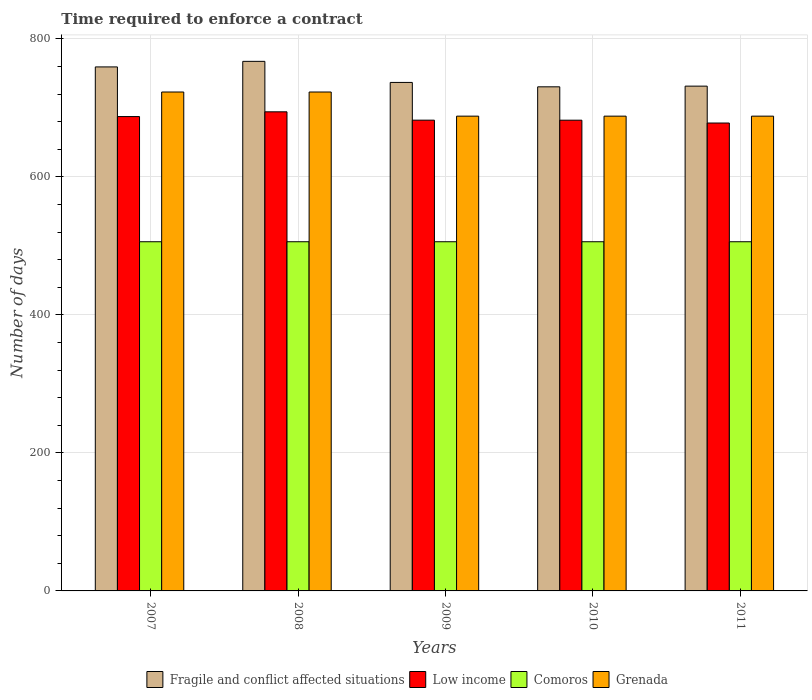How many groups of bars are there?
Give a very brief answer. 5. Are the number of bars on each tick of the X-axis equal?
Give a very brief answer. Yes. What is the label of the 4th group of bars from the left?
Offer a very short reply. 2010. What is the number of days required to enforce a contract in Low income in 2011?
Ensure brevity in your answer.  678.04. Across all years, what is the maximum number of days required to enforce a contract in Grenada?
Ensure brevity in your answer.  723. Across all years, what is the minimum number of days required to enforce a contract in Grenada?
Keep it short and to the point. 688. In which year was the number of days required to enforce a contract in Low income minimum?
Make the answer very short. 2011. What is the total number of days required to enforce a contract in Comoros in the graph?
Offer a very short reply. 2530. What is the difference between the number of days required to enforce a contract in Low income in 2007 and the number of days required to enforce a contract in Comoros in 2009?
Make the answer very short. 181.39. What is the average number of days required to enforce a contract in Grenada per year?
Provide a short and direct response. 702. In the year 2009, what is the difference between the number of days required to enforce a contract in Fragile and conflict affected situations and number of days required to enforce a contract in Grenada?
Your answer should be compact. 48.87. In how many years, is the number of days required to enforce a contract in Fragile and conflict affected situations greater than 360 days?
Offer a very short reply. 5. What is the ratio of the number of days required to enforce a contract in Low income in 2008 to that in 2011?
Provide a short and direct response. 1.02. What is the difference between the highest and the second highest number of days required to enforce a contract in Comoros?
Ensure brevity in your answer.  0. In how many years, is the number of days required to enforce a contract in Low income greater than the average number of days required to enforce a contract in Low income taken over all years?
Offer a terse response. 2. Is the sum of the number of days required to enforce a contract in Low income in 2009 and 2010 greater than the maximum number of days required to enforce a contract in Grenada across all years?
Your response must be concise. Yes. What does the 1st bar from the left in 2007 represents?
Ensure brevity in your answer.  Fragile and conflict affected situations. Is it the case that in every year, the sum of the number of days required to enforce a contract in Low income and number of days required to enforce a contract in Fragile and conflict affected situations is greater than the number of days required to enforce a contract in Grenada?
Your response must be concise. Yes. How many bars are there?
Provide a succinct answer. 20. Are the values on the major ticks of Y-axis written in scientific E-notation?
Offer a very short reply. No. Does the graph contain any zero values?
Ensure brevity in your answer.  No. Does the graph contain grids?
Keep it short and to the point. Yes. Where does the legend appear in the graph?
Keep it short and to the point. Bottom center. How many legend labels are there?
Your answer should be compact. 4. What is the title of the graph?
Provide a succinct answer. Time required to enforce a contract. Does "Malaysia" appear as one of the legend labels in the graph?
Provide a short and direct response. No. What is the label or title of the Y-axis?
Make the answer very short. Number of days. What is the Number of days of Fragile and conflict affected situations in 2007?
Provide a succinct answer. 759.34. What is the Number of days of Low income in 2007?
Make the answer very short. 687.39. What is the Number of days of Comoros in 2007?
Give a very brief answer. 506. What is the Number of days in Grenada in 2007?
Offer a terse response. 723. What is the Number of days in Fragile and conflict affected situations in 2008?
Keep it short and to the point. 767.41. What is the Number of days in Low income in 2008?
Offer a very short reply. 694.29. What is the Number of days of Comoros in 2008?
Your answer should be compact. 506. What is the Number of days in Grenada in 2008?
Offer a very short reply. 723. What is the Number of days of Fragile and conflict affected situations in 2009?
Make the answer very short. 736.87. What is the Number of days of Low income in 2009?
Give a very brief answer. 682.18. What is the Number of days of Comoros in 2009?
Provide a short and direct response. 506. What is the Number of days in Grenada in 2009?
Ensure brevity in your answer.  688. What is the Number of days in Fragile and conflict affected situations in 2010?
Keep it short and to the point. 730.5. What is the Number of days in Low income in 2010?
Ensure brevity in your answer.  682.14. What is the Number of days of Comoros in 2010?
Keep it short and to the point. 506. What is the Number of days in Grenada in 2010?
Offer a terse response. 688. What is the Number of days in Fragile and conflict affected situations in 2011?
Ensure brevity in your answer.  731.5. What is the Number of days of Low income in 2011?
Ensure brevity in your answer.  678.04. What is the Number of days of Comoros in 2011?
Your answer should be very brief. 506. What is the Number of days in Grenada in 2011?
Your answer should be very brief. 688. Across all years, what is the maximum Number of days in Fragile and conflict affected situations?
Your answer should be compact. 767.41. Across all years, what is the maximum Number of days of Low income?
Provide a succinct answer. 694.29. Across all years, what is the maximum Number of days in Comoros?
Ensure brevity in your answer.  506. Across all years, what is the maximum Number of days of Grenada?
Your answer should be compact. 723. Across all years, what is the minimum Number of days in Fragile and conflict affected situations?
Your answer should be compact. 730.5. Across all years, what is the minimum Number of days in Low income?
Offer a terse response. 678.04. Across all years, what is the minimum Number of days of Comoros?
Offer a terse response. 506. Across all years, what is the minimum Number of days of Grenada?
Offer a very short reply. 688. What is the total Number of days in Fragile and conflict affected situations in the graph?
Offer a terse response. 3725.63. What is the total Number of days of Low income in the graph?
Ensure brevity in your answer.  3424.04. What is the total Number of days of Comoros in the graph?
Your answer should be very brief. 2530. What is the total Number of days in Grenada in the graph?
Ensure brevity in your answer.  3510. What is the difference between the Number of days in Fragile and conflict affected situations in 2007 and that in 2008?
Offer a very short reply. -8.07. What is the difference between the Number of days in Low income in 2007 and that in 2008?
Ensure brevity in your answer.  -6.89. What is the difference between the Number of days of Grenada in 2007 and that in 2008?
Provide a short and direct response. 0. What is the difference between the Number of days in Fragile and conflict affected situations in 2007 and that in 2009?
Offer a terse response. 22.48. What is the difference between the Number of days of Low income in 2007 and that in 2009?
Keep it short and to the point. 5.21. What is the difference between the Number of days in Fragile and conflict affected situations in 2007 and that in 2010?
Provide a short and direct response. 28.84. What is the difference between the Number of days in Low income in 2007 and that in 2010?
Keep it short and to the point. 5.25. What is the difference between the Number of days of Comoros in 2007 and that in 2010?
Provide a short and direct response. 0. What is the difference between the Number of days in Grenada in 2007 and that in 2010?
Give a very brief answer. 35. What is the difference between the Number of days of Fragile and conflict affected situations in 2007 and that in 2011?
Ensure brevity in your answer.  27.84. What is the difference between the Number of days in Low income in 2007 and that in 2011?
Give a very brief answer. 9.36. What is the difference between the Number of days in Comoros in 2007 and that in 2011?
Offer a very short reply. 0. What is the difference between the Number of days of Fragile and conflict affected situations in 2008 and that in 2009?
Offer a terse response. 30.55. What is the difference between the Number of days of Low income in 2008 and that in 2009?
Your response must be concise. 12.11. What is the difference between the Number of days of Comoros in 2008 and that in 2009?
Keep it short and to the point. 0. What is the difference between the Number of days of Fragile and conflict affected situations in 2008 and that in 2010?
Offer a very short reply. 36.91. What is the difference between the Number of days in Low income in 2008 and that in 2010?
Give a very brief answer. 12.14. What is the difference between the Number of days in Fragile and conflict affected situations in 2008 and that in 2011?
Offer a very short reply. 35.91. What is the difference between the Number of days of Low income in 2008 and that in 2011?
Provide a short and direct response. 16.25. What is the difference between the Number of days in Grenada in 2008 and that in 2011?
Your answer should be compact. 35. What is the difference between the Number of days of Fragile and conflict affected situations in 2009 and that in 2010?
Keep it short and to the point. 6.37. What is the difference between the Number of days of Low income in 2009 and that in 2010?
Make the answer very short. 0.04. What is the difference between the Number of days of Fragile and conflict affected situations in 2009 and that in 2011?
Provide a short and direct response. 5.37. What is the difference between the Number of days in Low income in 2009 and that in 2011?
Offer a terse response. 4.14. What is the difference between the Number of days of Comoros in 2009 and that in 2011?
Ensure brevity in your answer.  0. What is the difference between the Number of days in Low income in 2010 and that in 2011?
Provide a short and direct response. 4.11. What is the difference between the Number of days of Fragile and conflict affected situations in 2007 and the Number of days of Low income in 2008?
Your response must be concise. 65.06. What is the difference between the Number of days of Fragile and conflict affected situations in 2007 and the Number of days of Comoros in 2008?
Make the answer very short. 253.34. What is the difference between the Number of days of Fragile and conflict affected situations in 2007 and the Number of days of Grenada in 2008?
Your answer should be very brief. 36.34. What is the difference between the Number of days in Low income in 2007 and the Number of days in Comoros in 2008?
Provide a short and direct response. 181.39. What is the difference between the Number of days of Low income in 2007 and the Number of days of Grenada in 2008?
Offer a terse response. -35.61. What is the difference between the Number of days of Comoros in 2007 and the Number of days of Grenada in 2008?
Ensure brevity in your answer.  -217. What is the difference between the Number of days in Fragile and conflict affected situations in 2007 and the Number of days in Low income in 2009?
Your answer should be compact. 77.17. What is the difference between the Number of days in Fragile and conflict affected situations in 2007 and the Number of days in Comoros in 2009?
Your response must be concise. 253.34. What is the difference between the Number of days in Fragile and conflict affected situations in 2007 and the Number of days in Grenada in 2009?
Your response must be concise. 71.34. What is the difference between the Number of days in Low income in 2007 and the Number of days in Comoros in 2009?
Your answer should be compact. 181.39. What is the difference between the Number of days in Low income in 2007 and the Number of days in Grenada in 2009?
Provide a short and direct response. -0.61. What is the difference between the Number of days in Comoros in 2007 and the Number of days in Grenada in 2009?
Provide a short and direct response. -182. What is the difference between the Number of days of Fragile and conflict affected situations in 2007 and the Number of days of Low income in 2010?
Make the answer very short. 77.2. What is the difference between the Number of days of Fragile and conflict affected situations in 2007 and the Number of days of Comoros in 2010?
Offer a terse response. 253.34. What is the difference between the Number of days in Fragile and conflict affected situations in 2007 and the Number of days in Grenada in 2010?
Provide a succinct answer. 71.34. What is the difference between the Number of days in Low income in 2007 and the Number of days in Comoros in 2010?
Provide a succinct answer. 181.39. What is the difference between the Number of days of Low income in 2007 and the Number of days of Grenada in 2010?
Give a very brief answer. -0.61. What is the difference between the Number of days in Comoros in 2007 and the Number of days in Grenada in 2010?
Provide a short and direct response. -182. What is the difference between the Number of days in Fragile and conflict affected situations in 2007 and the Number of days in Low income in 2011?
Provide a succinct answer. 81.31. What is the difference between the Number of days of Fragile and conflict affected situations in 2007 and the Number of days of Comoros in 2011?
Keep it short and to the point. 253.34. What is the difference between the Number of days of Fragile and conflict affected situations in 2007 and the Number of days of Grenada in 2011?
Offer a very short reply. 71.34. What is the difference between the Number of days in Low income in 2007 and the Number of days in Comoros in 2011?
Give a very brief answer. 181.39. What is the difference between the Number of days in Low income in 2007 and the Number of days in Grenada in 2011?
Give a very brief answer. -0.61. What is the difference between the Number of days in Comoros in 2007 and the Number of days in Grenada in 2011?
Your answer should be very brief. -182. What is the difference between the Number of days in Fragile and conflict affected situations in 2008 and the Number of days in Low income in 2009?
Ensure brevity in your answer.  85.24. What is the difference between the Number of days in Fragile and conflict affected situations in 2008 and the Number of days in Comoros in 2009?
Provide a short and direct response. 261.41. What is the difference between the Number of days in Fragile and conflict affected situations in 2008 and the Number of days in Grenada in 2009?
Provide a short and direct response. 79.41. What is the difference between the Number of days in Low income in 2008 and the Number of days in Comoros in 2009?
Provide a succinct answer. 188.29. What is the difference between the Number of days in Low income in 2008 and the Number of days in Grenada in 2009?
Your answer should be compact. 6.29. What is the difference between the Number of days in Comoros in 2008 and the Number of days in Grenada in 2009?
Provide a short and direct response. -182. What is the difference between the Number of days of Fragile and conflict affected situations in 2008 and the Number of days of Low income in 2010?
Provide a short and direct response. 85.27. What is the difference between the Number of days in Fragile and conflict affected situations in 2008 and the Number of days in Comoros in 2010?
Offer a very short reply. 261.41. What is the difference between the Number of days in Fragile and conflict affected situations in 2008 and the Number of days in Grenada in 2010?
Your answer should be compact. 79.41. What is the difference between the Number of days of Low income in 2008 and the Number of days of Comoros in 2010?
Offer a very short reply. 188.29. What is the difference between the Number of days in Low income in 2008 and the Number of days in Grenada in 2010?
Offer a terse response. 6.29. What is the difference between the Number of days of Comoros in 2008 and the Number of days of Grenada in 2010?
Your answer should be compact. -182. What is the difference between the Number of days of Fragile and conflict affected situations in 2008 and the Number of days of Low income in 2011?
Provide a short and direct response. 89.38. What is the difference between the Number of days in Fragile and conflict affected situations in 2008 and the Number of days in Comoros in 2011?
Your answer should be very brief. 261.41. What is the difference between the Number of days in Fragile and conflict affected situations in 2008 and the Number of days in Grenada in 2011?
Ensure brevity in your answer.  79.41. What is the difference between the Number of days in Low income in 2008 and the Number of days in Comoros in 2011?
Your answer should be compact. 188.29. What is the difference between the Number of days in Low income in 2008 and the Number of days in Grenada in 2011?
Ensure brevity in your answer.  6.29. What is the difference between the Number of days in Comoros in 2008 and the Number of days in Grenada in 2011?
Make the answer very short. -182. What is the difference between the Number of days in Fragile and conflict affected situations in 2009 and the Number of days in Low income in 2010?
Your response must be concise. 54.72. What is the difference between the Number of days of Fragile and conflict affected situations in 2009 and the Number of days of Comoros in 2010?
Give a very brief answer. 230.87. What is the difference between the Number of days of Fragile and conflict affected situations in 2009 and the Number of days of Grenada in 2010?
Your answer should be compact. 48.87. What is the difference between the Number of days in Low income in 2009 and the Number of days in Comoros in 2010?
Your answer should be compact. 176.18. What is the difference between the Number of days of Low income in 2009 and the Number of days of Grenada in 2010?
Offer a terse response. -5.82. What is the difference between the Number of days in Comoros in 2009 and the Number of days in Grenada in 2010?
Ensure brevity in your answer.  -182. What is the difference between the Number of days in Fragile and conflict affected situations in 2009 and the Number of days in Low income in 2011?
Provide a succinct answer. 58.83. What is the difference between the Number of days of Fragile and conflict affected situations in 2009 and the Number of days of Comoros in 2011?
Ensure brevity in your answer.  230.87. What is the difference between the Number of days of Fragile and conflict affected situations in 2009 and the Number of days of Grenada in 2011?
Keep it short and to the point. 48.87. What is the difference between the Number of days of Low income in 2009 and the Number of days of Comoros in 2011?
Provide a succinct answer. 176.18. What is the difference between the Number of days of Low income in 2009 and the Number of days of Grenada in 2011?
Offer a very short reply. -5.82. What is the difference between the Number of days of Comoros in 2009 and the Number of days of Grenada in 2011?
Offer a very short reply. -182. What is the difference between the Number of days of Fragile and conflict affected situations in 2010 and the Number of days of Low income in 2011?
Your answer should be very brief. 52.46. What is the difference between the Number of days of Fragile and conflict affected situations in 2010 and the Number of days of Comoros in 2011?
Ensure brevity in your answer.  224.5. What is the difference between the Number of days of Fragile and conflict affected situations in 2010 and the Number of days of Grenada in 2011?
Provide a short and direct response. 42.5. What is the difference between the Number of days in Low income in 2010 and the Number of days in Comoros in 2011?
Offer a terse response. 176.14. What is the difference between the Number of days of Low income in 2010 and the Number of days of Grenada in 2011?
Offer a terse response. -5.86. What is the difference between the Number of days of Comoros in 2010 and the Number of days of Grenada in 2011?
Provide a short and direct response. -182. What is the average Number of days in Fragile and conflict affected situations per year?
Give a very brief answer. 745.13. What is the average Number of days of Low income per year?
Provide a succinct answer. 684.81. What is the average Number of days of Comoros per year?
Give a very brief answer. 506. What is the average Number of days of Grenada per year?
Keep it short and to the point. 702. In the year 2007, what is the difference between the Number of days in Fragile and conflict affected situations and Number of days in Low income?
Your answer should be compact. 71.95. In the year 2007, what is the difference between the Number of days in Fragile and conflict affected situations and Number of days in Comoros?
Ensure brevity in your answer.  253.34. In the year 2007, what is the difference between the Number of days in Fragile and conflict affected situations and Number of days in Grenada?
Your answer should be very brief. 36.34. In the year 2007, what is the difference between the Number of days in Low income and Number of days in Comoros?
Your response must be concise. 181.39. In the year 2007, what is the difference between the Number of days of Low income and Number of days of Grenada?
Provide a short and direct response. -35.61. In the year 2007, what is the difference between the Number of days in Comoros and Number of days in Grenada?
Your response must be concise. -217. In the year 2008, what is the difference between the Number of days of Fragile and conflict affected situations and Number of days of Low income?
Offer a very short reply. 73.13. In the year 2008, what is the difference between the Number of days of Fragile and conflict affected situations and Number of days of Comoros?
Offer a terse response. 261.41. In the year 2008, what is the difference between the Number of days in Fragile and conflict affected situations and Number of days in Grenada?
Provide a short and direct response. 44.41. In the year 2008, what is the difference between the Number of days in Low income and Number of days in Comoros?
Your answer should be compact. 188.29. In the year 2008, what is the difference between the Number of days in Low income and Number of days in Grenada?
Make the answer very short. -28.71. In the year 2008, what is the difference between the Number of days of Comoros and Number of days of Grenada?
Offer a terse response. -217. In the year 2009, what is the difference between the Number of days in Fragile and conflict affected situations and Number of days in Low income?
Your answer should be very brief. 54.69. In the year 2009, what is the difference between the Number of days of Fragile and conflict affected situations and Number of days of Comoros?
Ensure brevity in your answer.  230.87. In the year 2009, what is the difference between the Number of days of Fragile and conflict affected situations and Number of days of Grenada?
Offer a terse response. 48.87. In the year 2009, what is the difference between the Number of days in Low income and Number of days in Comoros?
Keep it short and to the point. 176.18. In the year 2009, what is the difference between the Number of days in Low income and Number of days in Grenada?
Your answer should be compact. -5.82. In the year 2009, what is the difference between the Number of days of Comoros and Number of days of Grenada?
Provide a succinct answer. -182. In the year 2010, what is the difference between the Number of days of Fragile and conflict affected situations and Number of days of Low income?
Give a very brief answer. 48.36. In the year 2010, what is the difference between the Number of days in Fragile and conflict affected situations and Number of days in Comoros?
Offer a very short reply. 224.5. In the year 2010, what is the difference between the Number of days in Fragile and conflict affected situations and Number of days in Grenada?
Offer a very short reply. 42.5. In the year 2010, what is the difference between the Number of days of Low income and Number of days of Comoros?
Keep it short and to the point. 176.14. In the year 2010, what is the difference between the Number of days of Low income and Number of days of Grenada?
Your answer should be compact. -5.86. In the year 2010, what is the difference between the Number of days of Comoros and Number of days of Grenada?
Keep it short and to the point. -182. In the year 2011, what is the difference between the Number of days in Fragile and conflict affected situations and Number of days in Low income?
Offer a terse response. 53.46. In the year 2011, what is the difference between the Number of days in Fragile and conflict affected situations and Number of days in Comoros?
Offer a terse response. 225.5. In the year 2011, what is the difference between the Number of days in Fragile and conflict affected situations and Number of days in Grenada?
Your answer should be compact. 43.5. In the year 2011, what is the difference between the Number of days of Low income and Number of days of Comoros?
Give a very brief answer. 172.04. In the year 2011, what is the difference between the Number of days in Low income and Number of days in Grenada?
Provide a succinct answer. -9.96. In the year 2011, what is the difference between the Number of days in Comoros and Number of days in Grenada?
Make the answer very short. -182. What is the ratio of the Number of days in Grenada in 2007 to that in 2008?
Your answer should be compact. 1. What is the ratio of the Number of days in Fragile and conflict affected situations in 2007 to that in 2009?
Ensure brevity in your answer.  1.03. What is the ratio of the Number of days of Low income in 2007 to that in 2009?
Offer a terse response. 1.01. What is the ratio of the Number of days of Grenada in 2007 to that in 2009?
Your response must be concise. 1.05. What is the ratio of the Number of days of Fragile and conflict affected situations in 2007 to that in 2010?
Keep it short and to the point. 1.04. What is the ratio of the Number of days of Low income in 2007 to that in 2010?
Offer a very short reply. 1.01. What is the ratio of the Number of days of Grenada in 2007 to that in 2010?
Your response must be concise. 1.05. What is the ratio of the Number of days in Fragile and conflict affected situations in 2007 to that in 2011?
Offer a terse response. 1.04. What is the ratio of the Number of days in Low income in 2007 to that in 2011?
Keep it short and to the point. 1.01. What is the ratio of the Number of days of Grenada in 2007 to that in 2011?
Ensure brevity in your answer.  1.05. What is the ratio of the Number of days in Fragile and conflict affected situations in 2008 to that in 2009?
Offer a terse response. 1.04. What is the ratio of the Number of days in Low income in 2008 to that in 2009?
Make the answer very short. 1.02. What is the ratio of the Number of days in Comoros in 2008 to that in 2009?
Offer a terse response. 1. What is the ratio of the Number of days of Grenada in 2008 to that in 2009?
Offer a terse response. 1.05. What is the ratio of the Number of days in Fragile and conflict affected situations in 2008 to that in 2010?
Provide a succinct answer. 1.05. What is the ratio of the Number of days of Low income in 2008 to that in 2010?
Provide a succinct answer. 1.02. What is the ratio of the Number of days of Grenada in 2008 to that in 2010?
Your answer should be compact. 1.05. What is the ratio of the Number of days in Fragile and conflict affected situations in 2008 to that in 2011?
Your response must be concise. 1.05. What is the ratio of the Number of days of Low income in 2008 to that in 2011?
Offer a very short reply. 1.02. What is the ratio of the Number of days in Comoros in 2008 to that in 2011?
Make the answer very short. 1. What is the ratio of the Number of days in Grenada in 2008 to that in 2011?
Offer a terse response. 1.05. What is the ratio of the Number of days in Fragile and conflict affected situations in 2009 to that in 2010?
Offer a terse response. 1.01. What is the ratio of the Number of days in Fragile and conflict affected situations in 2009 to that in 2011?
Offer a very short reply. 1.01. What is the ratio of the Number of days in Fragile and conflict affected situations in 2010 to that in 2011?
Your response must be concise. 1. What is the ratio of the Number of days of Low income in 2010 to that in 2011?
Your answer should be compact. 1.01. What is the ratio of the Number of days in Comoros in 2010 to that in 2011?
Give a very brief answer. 1. What is the ratio of the Number of days in Grenada in 2010 to that in 2011?
Ensure brevity in your answer.  1. What is the difference between the highest and the second highest Number of days of Fragile and conflict affected situations?
Provide a short and direct response. 8.07. What is the difference between the highest and the second highest Number of days in Low income?
Keep it short and to the point. 6.89. What is the difference between the highest and the second highest Number of days of Comoros?
Ensure brevity in your answer.  0. What is the difference between the highest and the second highest Number of days in Grenada?
Give a very brief answer. 0. What is the difference between the highest and the lowest Number of days of Fragile and conflict affected situations?
Your answer should be very brief. 36.91. What is the difference between the highest and the lowest Number of days in Low income?
Your response must be concise. 16.25. What is the difference between the highest and the lowest Number of days in Comoros?
Make the answer very short. 0. 